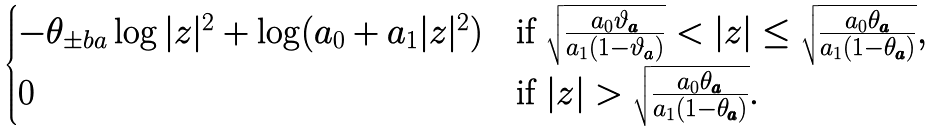<formula> <loc_0><loc_0><loc_500><loc_500>\begin{cases} - \theta _ { \pm b { a } } \log | z | ^ { 2 } + \log ( a _ { 0 } + a _ { 1 } | z | ^ { 2 } ) & \text {if $\sqrt{\frac{a_{0}\vartheta_{\pmb{a}}}{a_{1}(1-\vartheta_{\pmb{a}})}} < | z | \leq \sqrt{\frac{a_{0}\theta_{\pmb{a}}}{a_{1}(1-\theta_{\pmb{a}})}}$} , \\ 0 & \text {if $| z | > \sqrt{\frac{a_{0}\theta_{\pmb{a}}}{a_{1}(1-\theta_{\pmb{a}})}}$} . \end{cases}</formula> 